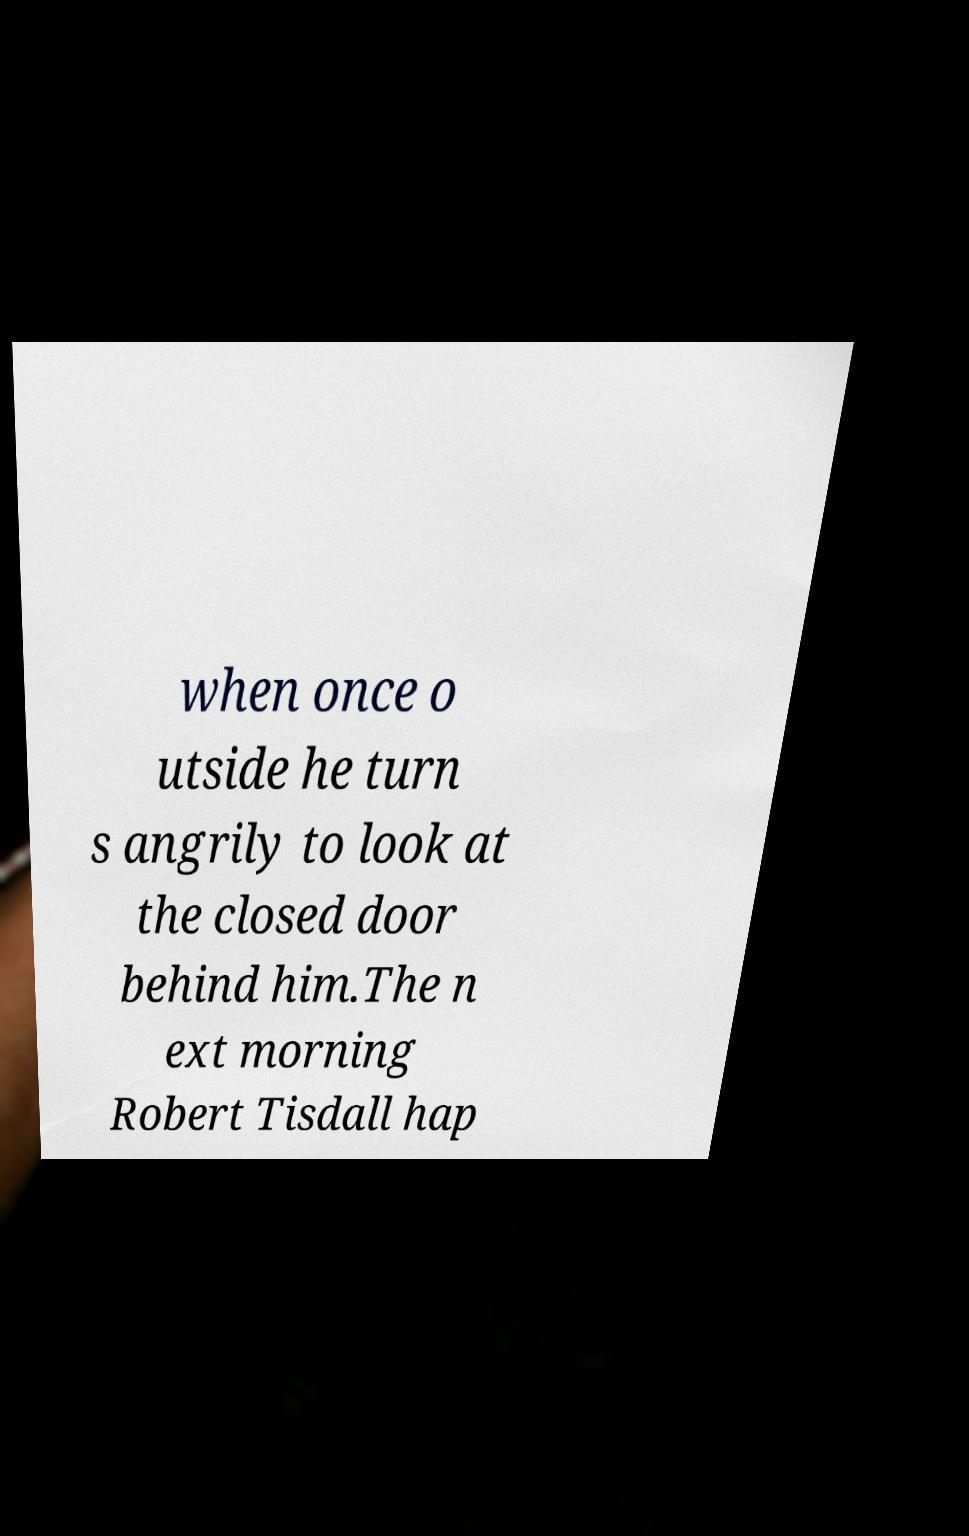Can you accurately transcribe the text from the provided image for me? when once o utside he turn s angrily to look at the closed door behind him.The n ext morning Robert Tisdall hap 